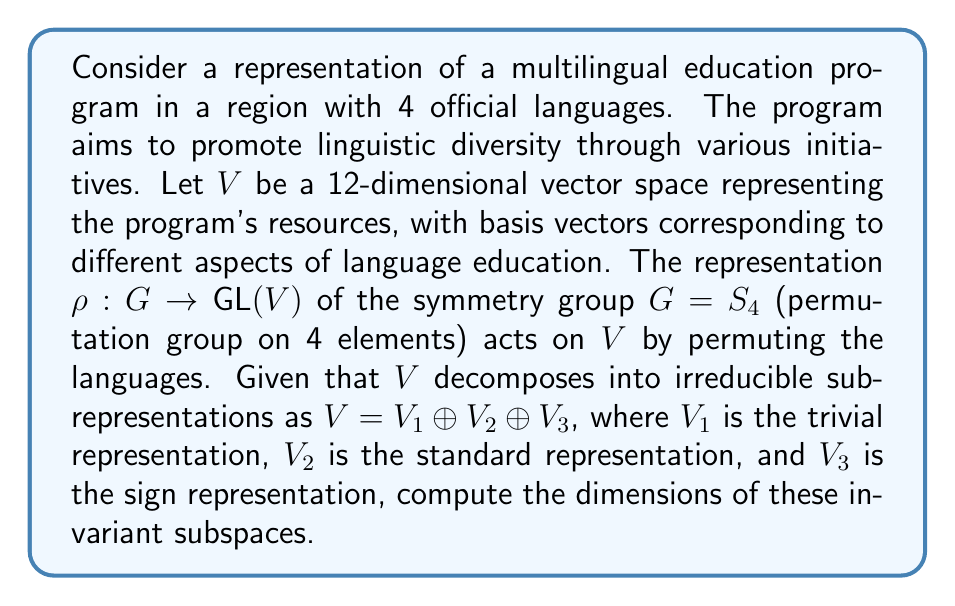Help me with this question. To solve this problem, we need to follow these steps:

1) Recall the dimensions of the irreducible representations of $S_4$:
   - Trivial representation ($V_1$): 1-dimensional
   - Standard representation ($V_2$): 3-dimensional
   - Sign representation ($V_3$): 1-dimensional

2) We know that $V$ is 12-dimensional, and it decomposes as $V = V_1 \oplus V_2 \oplus V_3$.

3) Let $d_1$, $d_2$, and $d_3$ be the number of times $V_1$, $V_2$, and $V_3$ appear in the decomposition, respectively.

4) We can set up an equation based on the total dimension:

   $$12 = 1d_1 + 3d_2 + 1d_3$$

5) In representation theory, the trivial representation often appears once, representing the "average" or "sum" of all languages. The sign representation typically appears once as well, representing the "alternating sum". So we can assume $d_1 = d_3 = 1$.

6) Substituting these values:

   $$12 = 1(1) + 3d_2 + 1(1)$$
   $$10 = 3d_2$$
   $$d_2 = \frac{10}{3}$$

7) Since $d_2$ must be an integer, we conclude that $d_2 = 3$.

8) Therefore, the decomposition is:

   $$V = V_1 \oplus V_2 \oplus V_2 \oplus V_2 \oplus V_3$$

9) The dimensions of the invariant subspaces are:
   - $\dim(V_1) = 1$
   - $\dim(V_2 \oplus V_2 \oplus V_2) = 3 + 3 + 3 = 9$
   - $\dim(V_3) = 1$
Answer: 1, 9, 1 